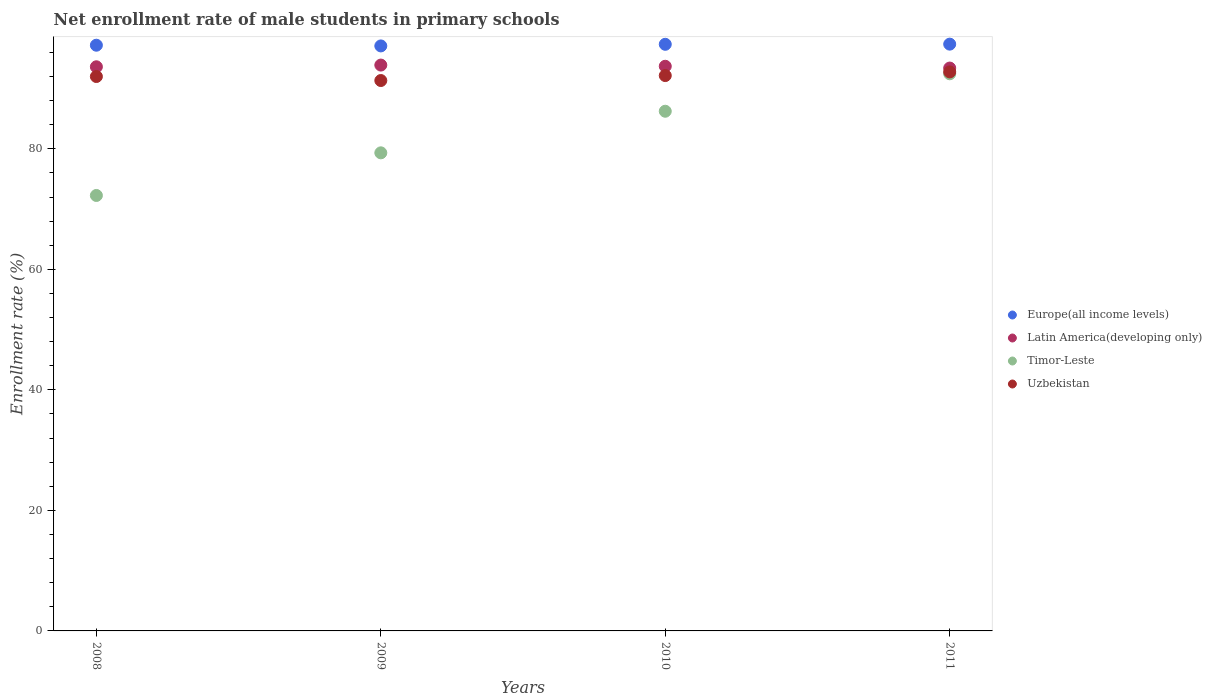How many different coloured dotlines are there?
Make the answer very short. 4. What is the net enrollment rate of male students in primary schools in Timor-Leste in 2008?
Your answer should be very brief. 72.26. Across all years, what is the maximum net enrollment rate of male students in primary schools in Europe(all income levels)?
Offer a very short reply. 97.37. Across all years, what is the minimum net enrollment rate of male students in primary schools in Europe(all income levels)?
Ensure brevity in your answer.  97.08. In which year was the net enrollment rate of male students in primary schools in Timor-Leste maximum?
Keep it short and to the point. 2011. In which year was the net enrollment rate of male students in primary schools in Uzbekistan minimum?
Offer a terse response. 2009. What is the total net enrollment rate of male students in primary schools in Timor-Leste in the graph?
Give a very brief answer. 330.29. What is the difference between the net enrollment rate of male students in primary schools in Timor-Leste in 2010 and that in 2011?
Keep it short and to the point. -6.22. What is the difference between the net enrollment rate of male students in primary schools in Europe(all income levels) in 2009 and the net enrollment rate of male students in primary schools in Latin America(developing only) in 2010?
Your answer should be very brief. 3.38. What is the average net enrollment rate of male students in primary schools in Latin America(developing only) per year?
Provide a short and direct response. 93.66. In the year 2008, what is the difference between the net enrollment rate of male students in primary schools in Timor-Leste and net enrollment rate of male students in primary schools in Europe(all income levels)?
Your answer should be compact. -24.93. In how many years, is the net enrollment rate of male students in primary schools in Uzbekistan greater than 12 %?
Make the answer very short. 4. What is the ratio of the net enrollment rate of male students in primary schools in Uzbekistan in 2009 to that in 2010?
Make the answer very short. 0.99. Is the difference between the net enrollment rate of male students in primary schools in Timor-Leste in 2008 and 2011 greater than the difference between the net enrollment rate of male students in primary schools in Europe(all income levels) in 2008 and 2011?
Ensure brevity in your answer.  No. What is the difference between the highest and the second highest net enrollment rate of male students in primary schools in Timor-Leste?
Provide a succinct answer. 6.22. What is the difference between the highest and the lowest net enrollment rate of male students in primary schools in Europe(all income levels)?
Provide a short and direct response. 0.3. In how many years, is the net enrollment rate of male students in primary schools in Latin America(developing only) greater than the average net enrollment rate of male students in primary schools in Latin America(developing only) taken over all years?
Keep it short and to the point. 2. Is the sum of the net enrollment rate of male students in primary schools in Europe(all income levels) in 2008 and 2011 greater than the maximum net enrollment rate of male students in primary schools in Timor-Leste across all years?
Your response must be concise. Yes. Is it the case that in every year, the sum of the net enrollment rate of male students in primary schools in Uzbekistan and net enrollment rate of male students in primary schools in Europe(all income levels)  is greater than the net enrollment rate of male students in primary schools in Latin America(developing only)?
Make the answer very short. Yes. Does the net enrollment rate of male students in primary schools in Europe(all income levels) monotonically increase over the years?
Your answer should be very brief. No. How many dotlines are there?
Give a very brief answer. 4. What is the difference between two consecutive major ticks on the Y-axis?
Keep it short and to the point. 20. Are the values on the major ticks of Y-axis written in scientific E-notation?
Ensure brevity in your answer.  No. Does the graph contain any zero values?
Make the answer very short. No. Where does the legend appear in the graph?
Your answer should be compact. Center right. How many legend labels are there?
Your response must be concise. 4. How are the legend labels stacked?
Make the answer very short. Vertical. What is the title of the graph?
Give a very brief answer. Net enrollment rate of male students in primary schools. Does "Haiti" appear as one of the legend labels in the graph?
Ensure brevity in your answer.  No. What is the label or title of the Y-axis?
Provide a short and direct response. Enrollment rate (%). What is the Enrollment rate (%) of Europe(all income levels) in 2008?
Your answer should be compact. 97.19. What is the Enrollment rate (%) in Latin America(developing only) in 2008?
Provide a succinct answer. 93.62. What is the Enrollment rate (%) in Timor-Leste in 2008?
Keep it short and to the point. 72.26. What is the Enrollment rate (%) of Uzbekistan in 2008?
Ensure brevity in your answer.  92. What is the Enrollment rate (%) in Europe(all income levels) in 2009?
Your response must be concise. 97.08. What is the Enrollment rate (%) of Latin America(developing only) in 2009?
Your answer should be very brief. 93.9. What is the Enrollment rate (%) in Timor-Leste in 2009?
Offer a terse response. 79.34. What is the Enrollment rate (%) in Uzbekistan in 2009?
Make the answer very short. 91.33. What is the Enrollment rate (%) in Europe(all income levels) in 2010?
Offer a terse response. 97.35. What is the Enrollment rate (%) of Latin America(developing only) in 2010?
Your answer should be very brief. 93.7. What is the Enrollment rate (%) of Timor-Leste in 2010?
Your answer should be compact. 86.24. What is the Enrollment rate (%) in Uzbekistan in 2010?
Give a very brief answer. 92.16. What is the Enrollment rate (%) of Europe(all income levels) in 2011?
Keep it short and to the point. 97.37. What is the Enrollment rate (%) of Latin America(developing only) in 2011?
Ensure brevity in your answer.  93.4. What is the Enrollment rate (%) of Timor-Leste in 2011?
Your answer should be very brief. 92.45. What is the Enrollment rate (%) in Uzbekistan in 2011?
Make the answer very short. 92.76. Across all years, what is the maximum Enrollment rate (%) in Europe(all income levels)?
Keep it short and to the point. 97.37. Across all years, what is the maximum Enrollment rate (%) in Latin America(developing only)?
Your response must be concise. 93.9. Across all years, what is the maximum Enrollment rate (%) of Timor-Leste?
Offer a terse response. 92.45. Across all years, what is the maximum Enrollment rate (%) of Uzbekistan?
Give a very brief answer. 92.76. Across all years, what is the minimum Enrollment rate (%) of Europe(all income levels)?
Your answer should be very brief. 97.08. Across all years, what is the minimum Enrollment rate (%) in Latin America(developing only)?
Give a very brief answer. 93.4. Across all years, what is the minimum Enrollment rate (%) in Timor-Leste?
Your answer should be very brief. 72.26. Across all years, what is the minimum Enrollment rate (%) of Uzbekistan?
Your response must be concise. 91.33. What is the total Enrollment rate (%) in Europe(all income levels) in the graph?
Your answer should be very brief. 388.99. What is the total Enrollment rate (%) of Latin America(developing only) in the graph?
Keep it short and to the point. 374.62. What is the total Enrollment rate (%) in Timor-Leste in the graph?
Keep it short and to the point. 330.29. What is the total Enrollment rate (%) of Uzbekistan in the graph?
Offer a terse response. 368.26. What is the difference between the Enrollment rate (%) in Europe(all income levels) in 2008 and that in 2009?
Your answer should be compact. 0.12. What is the difference between the Enrollment rate (%) in Latin America(developing only) in 2008 and that in 2009?
Offer a very short reply. -0.28. What is the difference between the Enrollment rate (%) in Timor-Leste in 2008 and that in 2009?
Keep it short and to the point. -7.08. What is the difference between the Enrollment rate (%) of Europe(all income levels) in 2008 and that in 2010?
Your response must be concise. -0.15. What is the difference between the Enrollment rate (%) in Latin America(developing only) in 2008 and that in 2010?
Provide a succinct answer. -0.09. What is the difference between the Enrollment rate (%) in Timor-Leste in 2008 and that in 2010?
Your response must be concise. -13.98. What is the difference between the Enrollment rate (%) in Uzbekistan in 2008 and that in 2010?
Your answer should be very brief. -0.16. What is the difference between the Enrollment rate (%) in Europe(all income levels) in 2008 and that in 2011?
Ensure brevity in your answer.  -0.18. What is the difference between the Enrollment rate (%) of Latin America(developing only) in 2008 and that in 2011?
Keep it short and to the point. 0.21. What is the difference between the Enrollment rate (%) of Timor-Leste in 2008 and that in 2011?
Your response must be concise. -20.19. What is the difference between the Enrollment rate (%) of Uzbekistan in 2008 and that in 2011?
Give a very brief answer. -0.76. What is the difference between the Enrollment rate (%) in Europe(all income levels) in 2009 and that in 2010?
Your answer should be very brief. -0.27. What is the difference between the Enrollment rate (%) in Latin America(developing only) in 2009 and that in 2010?
Keep it short and to the point. 0.2. What is the difference between the Enrollment rate (%) in Timor-Leste in 2009 and that in 2010?
Provide a short and direct response. -6.9. What is the difference between the Enrollment rate (%) of Uzbekistan in 2009 and that in 2010?
Give a very brief answer. -0.82. What is the difference between the Enrollment rate (%) in Europe(all income levels) in 2009 and that in 2011?
Provide a succinct answer. -0.3. What is the difference between the Enrollment rate (%) in Latin America(developing only) in 2009 and that in 2011?
Keep it short and to the point. 0.49. What is the difference between the Enrollment rate (%) of Timor-Leste in 2009 and that in 2011?
Provide a short and direct response. -13.12. What is the difference between the Enrollment rate (%) of Uzbekistan in 2009 and that in 2011?
Offer a terse response. -1.43. What is the difference between the Enrollment rate (%) of Europe(all income levels) in 2010 and that in 2011?
Your answer should be compact. -0.03. What is the difference between the Enrollment rate (%) in Latin America(developing only) in 2010 and that in 2011?
Ensure brevity in your answer.  0.3. What is the difference between the Enrollment rate (%) in Timor-Leste in 2010 and that in 2011?
Your answer should be compact. -6.22. What is the difference between the Enrollment rate (%) in Uzbekistan in 2010 and that in 2011?
Provide a short and direct response. -0.61. What is the difference between the Enrollment rate (%) in Europe(all income levels) in 2008 and the Enrollment rate (%) in Latin America(developing only) in 2009?
Ensure brevity in your answer.  3.29. What is the difference between the Enrollment rate (%) of Europe(all income levels) in 2008 and the Enrollment rate (%) of Timor-Leste in 2009?
Your answer should be very brief. 17.86. What is the difference between the Enrollment rate (%) in Europe(all income levels) in 2008 and the Enrollment rate (%) in Uzbekistan in 2009?
Provide a succinct answer. 5.86. What is the difference between the Enrollment rate (%) of Latin America(developing only) in 2008 and the Enrollment rate (%) of Timor-Leste in 2009?
Make the answer very short. 14.28. What is the difference between the Enrollment rate (%) of Latin America(developing only) in 2008 and the Enrollment rate (%) of Uzbekistan in 2009?
Your answer should be very brief. 2.28. What is the difference between the Enrollment rate (%) in Timor-Leste in 2008 and the Enrollment rate (%) in Uzbekistan in 2009?
Provide a succinct answer. -19.07. What is the difference between the Enrollment rate (%) of Europe(all income levels) in 2008 and the Enrollment rate (%) of Latin America(developing only) in 2010?
Ensure brevity in your answer.  3.49. What is the difference between the Enrollment rate (%) of Europe(all income levels) in 2008 and the Enrollment rate (%) of Timor-Leste in 2010?
Your response must be concise. 10.96. What is the difference between the Enrollment rate (%) in Europe(all income levels) in 2008 and the Enrollment rate (%) in Uzbekistan in 2010?
Keep it short and to the point. 5.04. What is the difference between the Enrollment rate (%) in Latin America(developing only) in 2008 and the Enrollment rate (%) in Timor-Leste in 2010?
Offer a terse response. 7.38. What is the difference between the Enrollment rate (%) of Latin America(developing only) in 2008 and the Enrollment rate (%) of Uzbekistan in 2010?
Your answer should be compact. 1.46. What is the difference between the Enrollment rate (%) of Timor-Leste in 2008 and the Enrollment rate (%) of Uzbekistan in 2010?
Your response must be concise. -19.9. What is the difference between the Enrollment rate (%) in Europe(all income levels) in 2008 and the Enrollment rate (%) in Latin America(developing only) in 2011?
Keep it short and to the point. 3.79. What is the difference between the Enrollment rate (%) in Europe(all income levels) in 2008 and the Enrollment rate (%) in Timor-Leste in 2011?
Your answer should be compact. 4.74. What is the difference between the Enrollment rate (%) of Europe(all income levels) in 2008 and the Enrollment rate (%) of Uzbekistan in 2011?
Your response must be concise. 4.43. What is the difference between the Enrollment rate (%) in Latin America(developing only) in 2008 and the Enrollment rate (%) in Timor-Leste in 2011?
Offer a terse response. 1.16. What is the difference between the Enrollment rate (%) in Latin America(developing only) in 2008 and the Enrollment rate (%) in Uzbekistan in 2011?
Keep it short and to the point. 0.85. What is the difference between the Enrollment rate (%) of Timor-Leste in 2008 and the Enrollment rate (%) of Uzbekistan in 2011?
Your response must be concise. -20.5. What is the difference between the Enrollment rate (%) of Europe(all income levels) in 2009 and the Enrollment rate (%) of Latin America(developing only) in 2010?
Ensure brevity in your answer.  3.38. What is the difference between the Enrollment rate (%) of Europe(all income levels) in 2009 and the Enrollment rate (%) of Timor-Leste in 2010?
Your answer should be very brief. 10.84. What is the difference between the Enrollment rate (%) in Europe(all income levels) in 2009 and the Enrollment rate (%) in Uzbekistan in 2010?
Provide a short and direct response. 4.92. What is the difference between the Enrollment rate (%) in Latin America(developing only) in 2009 and the Enrollment rate (%) in Timor-Leste in 2010?
Your answer should be very brief. 7.66. What is the difference between the Enrollment rate (%) in Latin America(developing only) in 2009 and the Enrollment rate (%) in Uzbekistan in 2010?
Make the answer very short. 1.74. What is the difference between the Enrollment rate (%) of Timor-Leste in 2009 and the Enrollment rate (%) of Uzbekistan in 2010?
Offer a very short reply. -12.82. What is the difference between the Enrollment rate (%) of Europe(all income levels) in 2009 and the Enrollment rate (%) of Latin America(developing only) in 2011?
Your response must be concise. 3.67. What is the difference between the Enrollment rate (%) of Europe(all income levels) in 2009 and the Enrollment rate (%) of Timor-Leste in 2011?
Provide a succinct answer. 4.62. What is the difference between the Enrollment rate (%) in Europe(all income levels) in 2009 and the Enrollment rate (%) in Uzbekistan in 2011?
Provide a succinct answer. 4.31. What is the difference between the Enrollment rate (%) in Latin America(developing only) in 2009 and the Enrollment rate (%) in Timor-Leste in 2011?
Your answer should be very brief. 1.45. What is the difference between the Enrollment rate (%) in Latin America(developing only) in 2009 and the Enrollment rate (%) in Uzbekistan in 2011?
Provide a succinct answer. 1.13. What is the difference between the Enrollment rate (%) of Timor-Leste in 2009 and the Enrollment rate (%) of Uzbekistan in 2011?
Make the answer very short. -13.43. What is the difference between the Enrollment rate (%) of Europe(all income levels) in 2010 and the Enrollment rate (%) of Latin America(developing only) in 2011?
Make the answer very short. 3.94. What is the difference between the Enrollment rate (%) of Europe(all income levels) in 2010 and the Enrollment rate (%) of Timor-Leste in 2011?
Your answer should be very brief. 4.89. What is the difference between the Enrollment rate (%) in Europe(all income levels) in 2010 and the Enrollment rate (%) in Uzbekistan in 2011?
Give a very brief answer. 4.58. What is the difference between the Enrollment rate (%) of Latin America(developing only) in 2010 and the Enrollment rate (%) of Timor-Leste in 2011?
Give a very brief answer. 1.25. What is the difference between the Enrollment rate (%) in Latin America(developing only) in 2010 and the Enrollment rate (%) in Uzbekistan in 2011?
Offer a very short reply. 0.94. What is the difference between the Enrollment rate (%) in Timor-Leste in 2010 and the Enrollment rate (%) in Uzbekistan in 2011?
Provide a succinct answer. -6.53. What is the average Enrollment rate (%) of Europe(all income levels) per year?
Give a very brief answer. 97.25. What is the average Enrollment rate (%) of Latin America(developing only) per year?
Keep it short and to the point. 93.66. What is the average Enrollment rate (%) in Timor-Leste per year?
Provide a succinct answer. 82.57. What is the average Enrollment rate (%) in Uzbekistan per year?
Provide a short and direct response. 92.06. In the year 2008, what is the difference between the Enrollment rate (%) of Europe(all income levels) and Enrollment rate (%) of Latin America(developing only)?
Offer a terse response. 3.58. In the year 2008, what is the difference between the Enrollment rate (%) in Europe(all income levels) and Enrollment rate (%) in Timor-Leste?
Your answer should be compact. 24.93. In the year 2008, what is the difference between the Enrollment rate (%) in Europe(all income levels) and Enrollment rate (%) in Uzbekistan?
Ensure brevity in your answer.  5.19. In the year 2008, what is the difference between the Enrollment rate (%) of Latin America(developing only) and Enrollment rate (%) of Timor-Leste?
Make the answer very short. 21.35. In the year 2008, what is the difference between the Enrollment rate (%) of Latin America(developing only) and Enrollment rate (%) of Uzbekistan?
Your response must be concise. 1.62. In the year 2008, what is the difference between the Enrollment rate (%) of Timor-Leste and Enrollment rate (%) of Uzbekistan?
Make the answer very short. -19.74. In the year 2009, what is the difference between the Enrollment rate (%) of Europe(all income levels) and Enrollment rate (%) of Latin America(developing only)?
Give a very brief answer. 3.18. In the year 2009, what is the difference between the Enrollment rate (%) of Europe(all income levels) and Enrollment rate (%) of Timor-Leste?
Ensure brevity in your answer.  17.74. In the year 2009, what is the difference between the Enrollment rate (%) in Europe(all income levels) and Enrollment rate (%) in Uzbekistan?
Ensure brevity in your answer.  5.74. In the year 2009, what is the difference between the Enrollment rate (%) of Latin America(developing only) and Enrollment rate (%) of Timor-Leste?
Ensure brevity in your answer.  14.56. In the year 2009, what is the difference between the Enrollment rate (%) in Latin America(developing only) and Enrollment rate (%) in Uzbekistan?
Provide a short and direct response. 2.57. In the year 2009, what is the difference between the Enrollment rate (%) of Timor-Leste and Enrollment rate (%) of Uzbekistan?
Your answer should be very brief. -12. In the year 2010, what is the difference between the Enrollment rate (%) in Europe(all income levels) and Enrollment rate (%) in Latin America(developing only)?
Your answer should be compact. 3.64. In the year 2010, what is the difference between the Enrollment rate (%) in Europe(all income levels) and Enrollment rate (%) in Timor-Leste?
Offer a terse response. 11.11. In the year 2010, what is the difference between the Enrollment rate (%) in Europe(all income levels) and Enrollment rate (%) in Uzbekistan?
Provide a short and direct response. 5.19. In the year 2010, what is the difference between the Enrollment rate (%) of Latin America(developing only) and Enrollment rate (%) of Timor-Leste?
Your response must be concise. 7.46. In the year 2010, what is the difference between the Enrollment rate (%) in Latin America(developing only) and Enrollment rate (%) in Uzbekistan?
Provide a succinct answer. 1.54. In the year 2010, what is the difference between the Enrollment rate (%) in Timor-Leste and Enrollment rate (%) in Uzbekistan?
Your answer should be compact. -5.92. In the year 2011, what is the difference between the Enrollment rate (%) of Europe(all income levels) and Enrollment rate (%) of Latin America(developing only)?
Provide a succinct answer. 3.97. In the year 2011, what is the difference between the Enrollment rate (%) of Europe(all income levels) and Enrollment rate (%) of Timor-Leste?
Give a very brief answer. 4.92. In the year 2011, what is the difference between the Enrollment rate (%) in Europe(all income levels) and Enrollment rate (%) in Uzbekistan?
Offer a very short reply. 4.61. In the year 2011, what is the difference between the Enrollment rate (%) in Latin America(developing only) and Enrollment rate (%) in Timor-Leste?
Offer a very short reply. 0.95. In the year 2011, what is the difference between the Enrollment rate (%) of Latin America(developing only) and Enrollment rate (%) of Uzbekistan?
Keep it short and to the point. 0.64. In the year 2011, what is the difference between the Enrollment rate (%) in Timor-Leste and Enrollment rate (%) in Uzbekistan?
Offer a very short reply. -0.31. What is the ratio of the Enrollment rate (%) of Timor-Leste in 2008 to that in 2009?
Give a very brief answer. 0.91. What is the ratio of the Enrollment rate (%) of Uzbekistan in 2008 to that in 2009?
Your response must be concise. 1.01. What is the ratio of the Enrollment rate (%) in Latin America(developing only) in 2008 to that in 2010?
Make the answer very short. 1. What is the ratio of the Enrollment rate (%) of Timor-Leste in 2008 to that in 2010?
Provide a succinct answer. 0.84. What is the ratio of the Enrollment rate (%) of Uzbekistan in 2008 to that in 2010?
Keep it short and to the point. 1. What is the ratio of the Enrollment rate (%) in Latin America(developing only) in 2008 to that in 2011?
Your response must be concise. 1. What is the ratio of the Enrollment rate (%) of Timor-Leste in 2008 to that in 2011?
Offer a very short reply. 0.78. What is the ratio of the Enrollment rate (%) in Uzbekistan in 2008 to that in 2011?
Provide a succinct answer. 0.99. What is the ratio of the Enrollment rate (%) of Uzbekistan in 2009 to that in 2010?
Offer a very short reply. 0.99. What is the ratio of the Enrollment rate (%) in Europe(all income levels) in 2009 to that in 2011?
Offer a terse response. 1. What is the ratio of the Enrollment rate (%) in Latin America(developing only) in 2009 to that in 2011?
Give a very brief answer. 1.01. What is the ratio of the Enrollment rate (%) in Timor-Leste in 2009 to that in 2011?
Your response must be concise. 0.86. What is the ratio of the Enrollment rate (%) of Uzbekistan in 2009 to that in 2011?
Keep it short and to the point. 0.98. What is the ratio of the Enrollment rate (%) in Latin America(developing only) in 2010 to that in 2011?
Your answer should be compact. 1. What is the ratio of the Enrollment rate (%) in Timor-Leste in 2010 to that in 2011?
Your answer should be very brief. 0.93. What is the difference between the highest and the second highest Enrollment rate (%) of Europe(all income levels)?
Your response must be concise. 0.03. What is the difference between the highest and the second highest Enrollment rate (%) in Latin America(developing only)?
Your answer should be compact. 0.2. What is the difference between the highest and the second highest Enrollment rate (%) of Timor-Leste?
Provide a succinct answer. 6.22. What is the difference between the highest and the second highest Enrollment rate (%) of Uzbekistan?
Offer a very short reply. 0.61. What is the difference between the highest and the lowest Enrollment rate (%) in Europe(all income levels)?
Offer a terse response. 0.3. What is the difference between the highest and the lowest Enrollment rate (%) in Latin America(developing only)?
Your response must be concise. 0.49. What is the difference between the highest and the lowest Enrollment rate (%) in Timor-Leste?
Your answer should be compact. 20.19. What is the difference between the highest and the lowest Enrollment rate (%) of Uzbekistan?
Your answer should be compact. 1.43. 